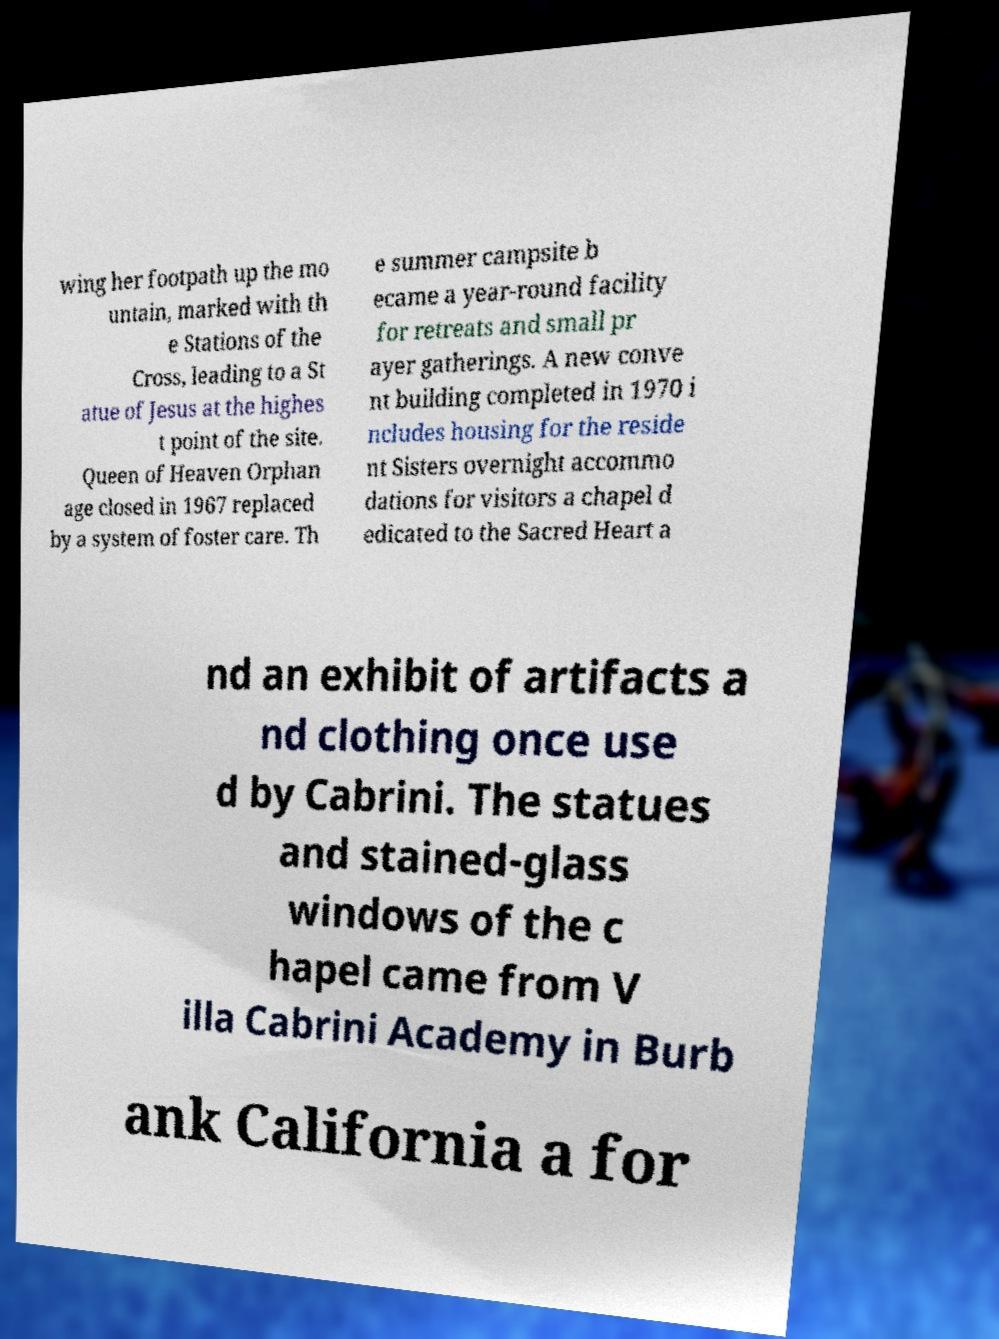Can you read and provide the text displayed in the image?This photo seems to have some interesting text. Can you extract and type it out for me? wing her footpath up the mo untain, marked with th e Stations of the Cross, leading to a St atue of Jesus at the highes t point of the site. Queen of Heaven Orphan age closed in 1967 replaced by a system of foster care. Th e summer campsite b ecame a year-round facility for retreats and small pr ayer gatherings. A new conve nt building completed in 1970 i ncludes housing for the reside nt Sisters overnight accommo dations for visitors a chapel d edicated to the Sacred Heart a nd an exhibit of artifacts a nd clothing once use d by Cabrini. The statues and stained-glass windows of the c hapel came from V illa Cabrini Academy in Burb ank California a for 